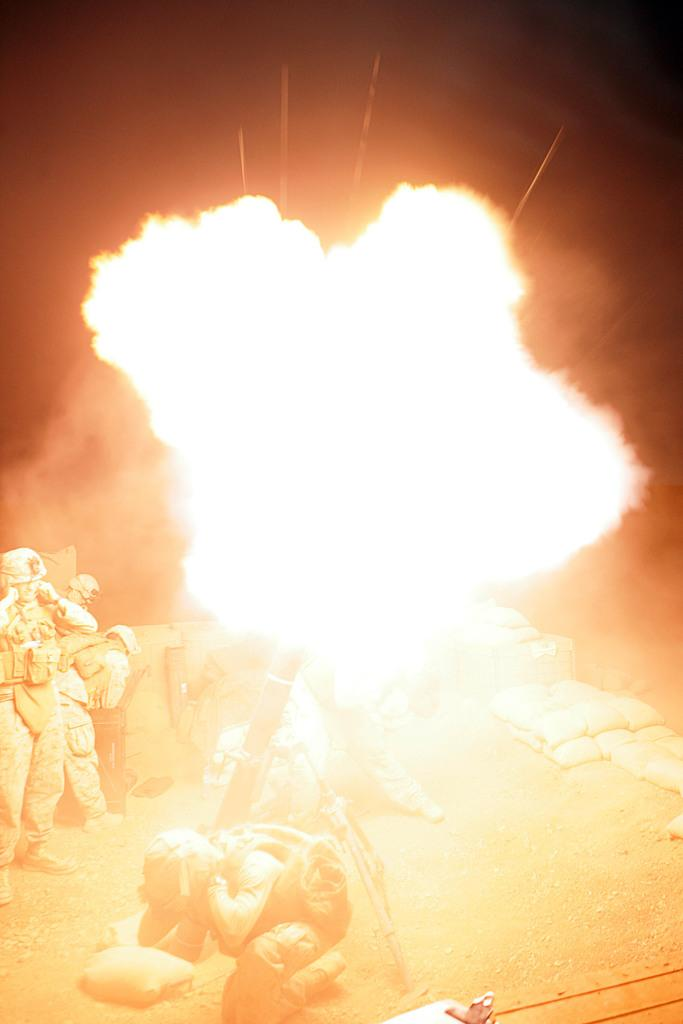What are the persons in the image wearing? The persons in the image are wearing uniforms and helmets. What can be seen on the land in the image? There are bags on the land in the image. What is the main feature in the middle of the image? There is fire in the middle of the image. What type of history can be seen in the image? There is no specific historical event or reference in the image; it features persons wearing uniforms and helmets, bags on the land, and fire in the middle. How many cows are present in the image? There are no cows present in the image. 